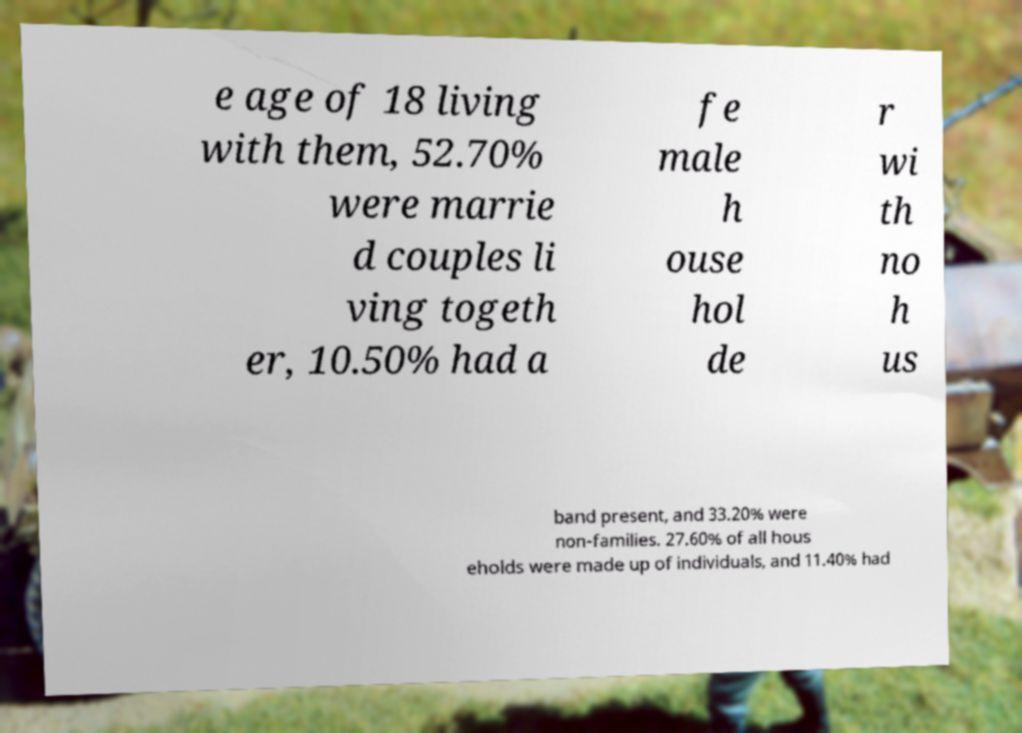Could you assist in decoding the text presented in this image and type it out clearly? e age of 18 living with them, 52.70% were marrie d couples li ving togeth er, 10.50% had a fe male h ouse hol de r wi th no h us band present, and 33.20% were non-families. 27.60% of all hous eholds were made up of individuals, and 11.40% had 